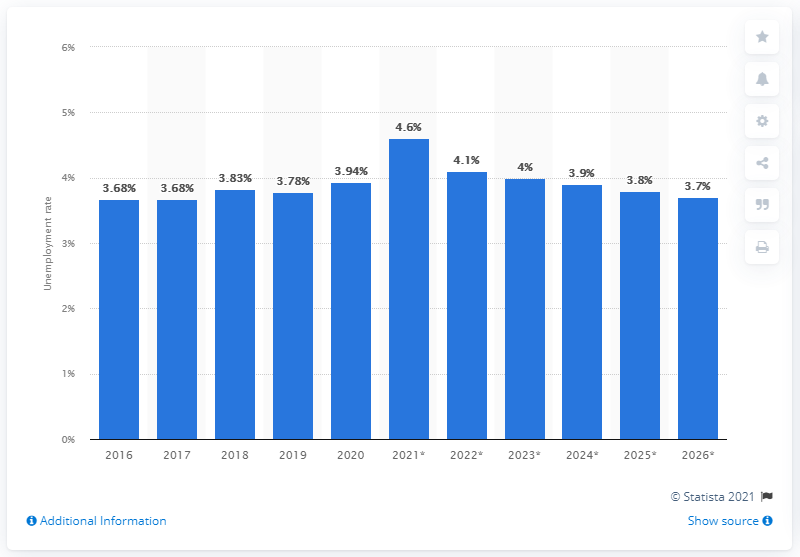Draw attention to some important aspects in this diagram. The unemployment rate in South Korea ended in 2020. 